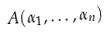<formula> <loc_0><loc_0><loc_500><loc_500>A ( \alpha _ { 1 } , \dots , \alpha _ { n } )</formula> 